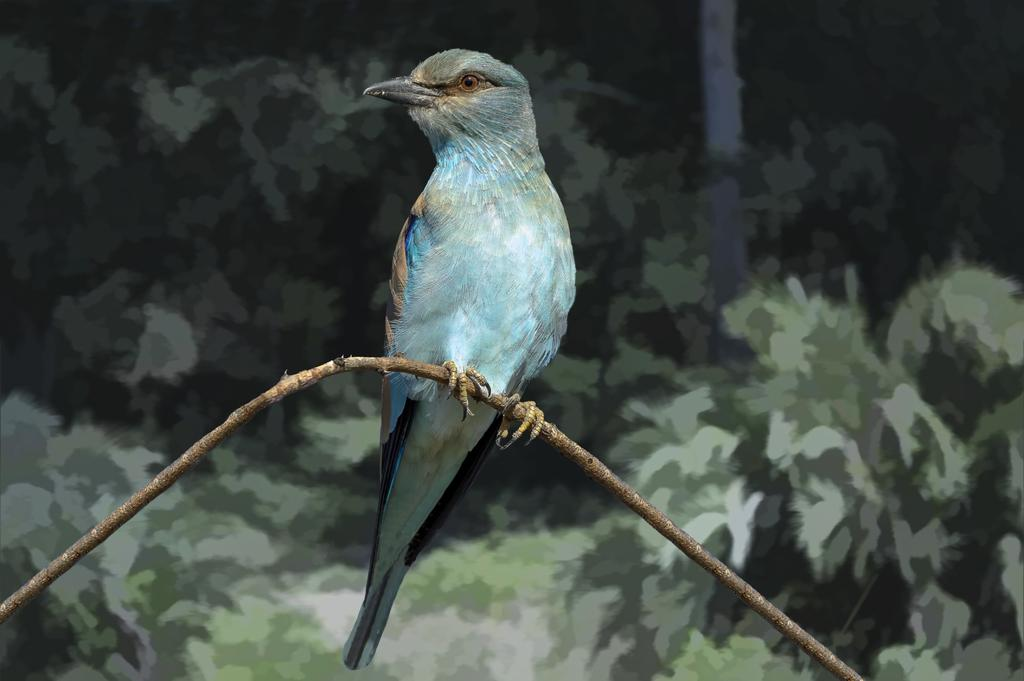What type of animal is in the image? There is a bird in the image. Where is the bird located? The bird is on a thin wooden stick. What color is the background of the image? The background of the image appears to be green. What might the green background be? The green background might be a wall. What type of tomatoes is your uncle growing in the image? There are no tomatoes or your uncle present in the image; it features a bird on a thin wooden stick with a green background. 